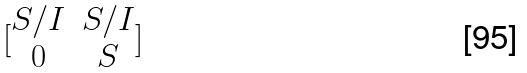<formula> <loc_0><loc_0><loc_500><loc_500>[ \begin{matrix} S / I & S / I \\ 0 & S \end{matrix} ]</formula> 